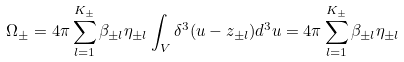<formula> <loc_0><loc_0><loc_500><loc_500>\Omega _ { \pm } = 4 \pi \sum _ { l = 1 } ^ { K _ { \pm } } \beta _ { \pm l } \eta _ { \pm l } \int _ { V } \delta ^ { 3 } ( u - z _ { \pm l } ) d ^ { 3 } u = 4 \pi \sum _ { l = 1 } ^ { K _ { \pm } } \beta _ { \pm l } \eta _ { \pm l }</formula> 